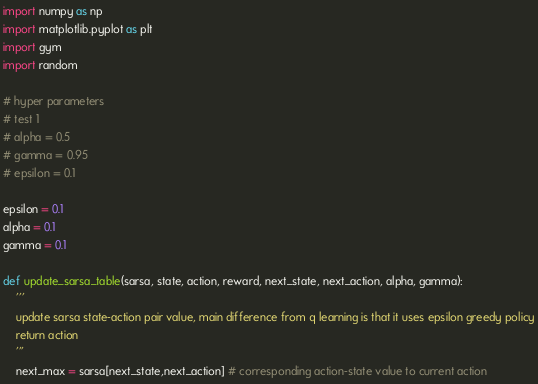Convert code to text. <code><loc_0><loc_0><loc_500><loc_500><_Python_>import numpy as np
import matplotlib.pyplot as plt
import gym
import random

# hyper parameters
# test 1
# alpha = 0.5
# gamma = 0.95
# epsilon = 0.1

epsilon = 0.1
alpha = 0.1
gamma = 0.1

def update_sarsa_table(sarsa, state, action, reward, next_state, next_action, alpha, gamma):
    '''
    update sarsa state-action pair value, main difference from q learning is that it uses epsilon greedy policy
    return action
    '''
    next_max = sarsa[next_state,next_action] # corresponding action-state value to current action
</code> 